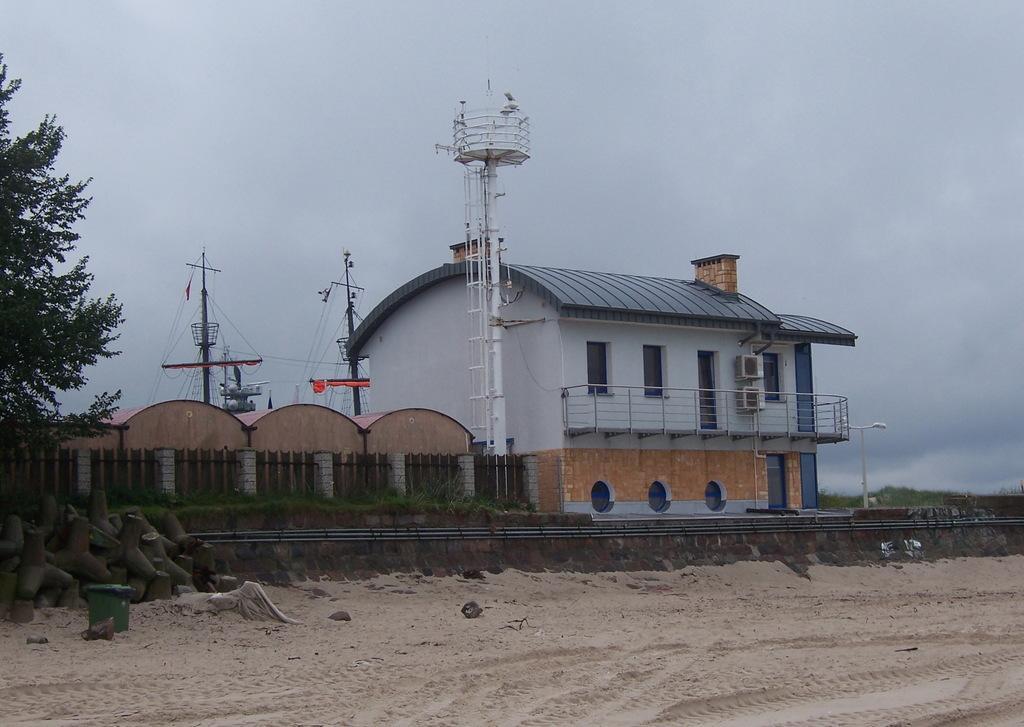How would you summarize this image in a sentence or two? In the middle it is a house which is in white color. In the left side there are trees at the top it's a sky. 